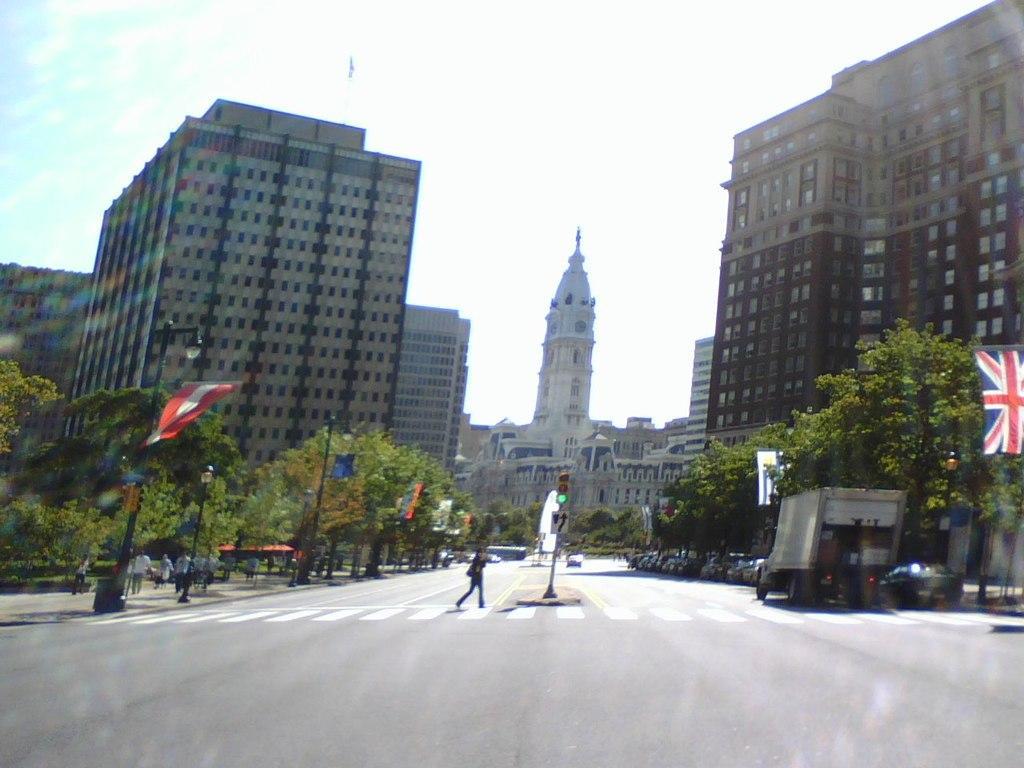Could you give a brief overview of what you see in this image? There is a road. On the road there is a zebra crossing and a person is walking on the zebra crossing. There are vehicles on the sides of the road. There is a traffic signal with a pole. Also there are trees, flags with poles on the sides of the road. In the back there are buildings, sky. Some people are walking on the sides of the road. 